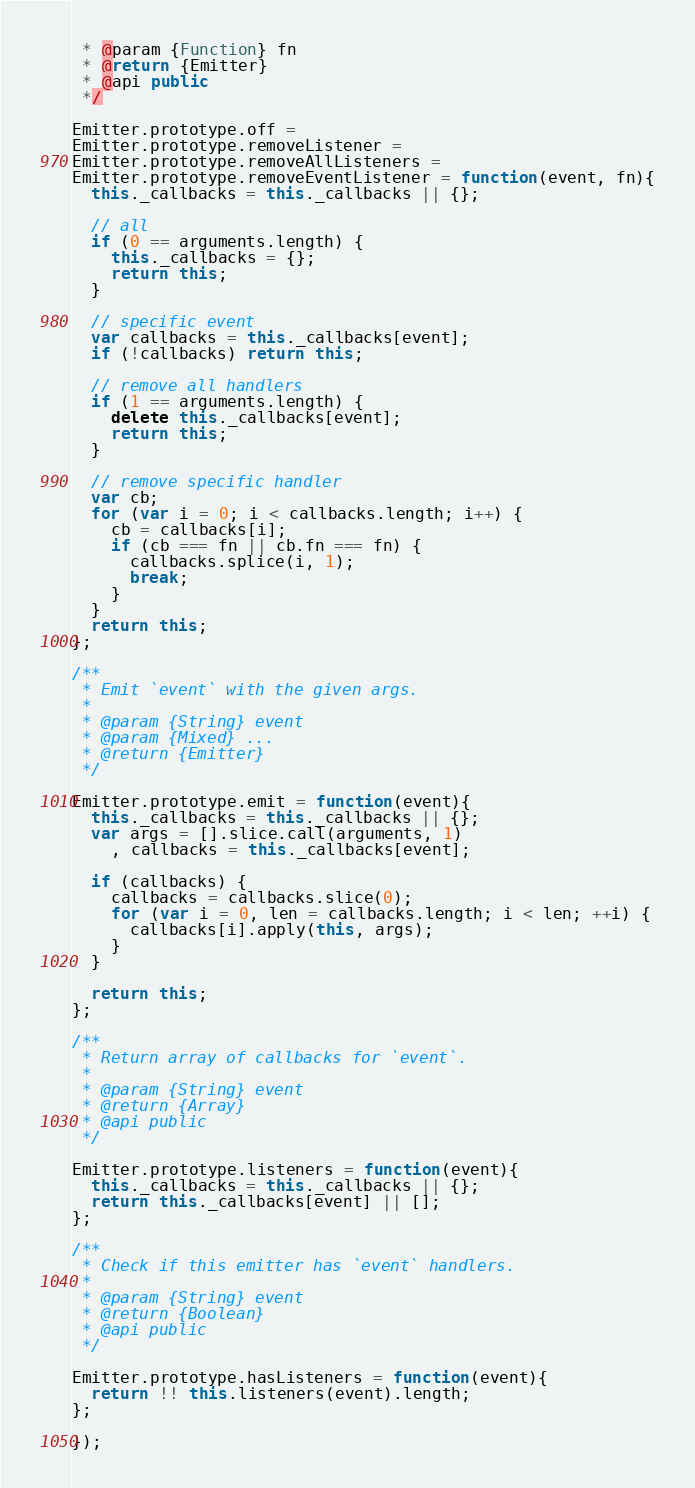Convert code to text. <code><loc_0><loc_0><loc_500><loc_500><_JavaScript_> * @param {Function} fn
 * @return {Emitter}
 * @api public
 */

Emitter.prototype.off =
Emitter.prototype.removeListener =
Emitter.prototype.removeAllListeners =
Emitter.prototype.removeEventListener = function(event, fn){
  this._callbacks = this._callbacks || {};

  // all
  if (0 == arguments.length) {
    this._callbacks = {};
    return this;
  }

  // specific event
  var callbacks = this._callbacks[event];
  if (!callbacks) return this;

  // remove all handlers
  if (1 == arguments.length) {
    delete this._callbacks[event];
    return this;
  }

  // remove specific handler
  var cb;
  for (var i = 0; i < callbacks.length; i++) {
    cb = callbacks[i];
    if (cb === fn || cb.fn === fn) {
      callbacks.splice(i, 1);
      break;
    }
  }
  return this;
};

/**
 * Emit `event` with the given args.
 *
 * @param {String} event
 * @param {Mixed} ...
 * @return {Emitter}
 */

Emitter.prototype.emit = function(event){
  this._callbacks = this._callbacks || {};
  var args = [].slice.call(arguments, 1)
    , callbacks = this._callbacks[event];

  if (callbacks) {
    callbacks = callbacks.slice(0);
    for (var i = 0, len = callbacks.length; i < len; ++i) {
      callbacks[i].apply(this, args);
    }
  }

  return this;
};

/**
 * Return array of callbacks for `event`.
 *
 * @param {String} event
 * @return {Array}
 * @api public
 */

Emitter.prototype.listeners = function(event){
  this._callbacks = this._callbacks || {};
  return this._callbacks[event] || [];
};

/**
 * Check if this emitter has `event` handlers.
 *
 * @param {String} event
 * @return {Boolean}
 * @api public
 */

Emitter.prototype.hasListeners = function(event){
  return !! this.listeners(event).length;
};

});</code> 